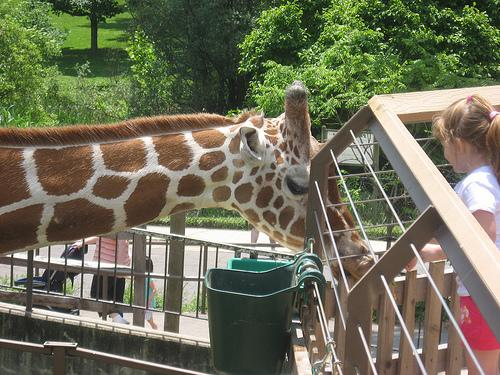Point out a few details about the giraffe's physical appearance. The giraffe has a brown and white pattern on its neck, downward-looking eyes, and horns on its head. List the primary human activities happening in the image. Little girl feeding giraffe, woman pushing baby stroller, child walking beside the stroller. Briefly describe the appearance of the trees in the scene. The trees have green leaves and stand tall in the background, providing a lush backdrop for the scene. In a few words, describe where the giraffe's food is placed and its color. The giraffe's food is in two green feed buckets near the wooden railing. Explain the position of the giraffe's head and what it appears to be doing. The giraffe's head is lowered, and its eye is looking downward as it eats from the girl's hand. Mention what surrounds the giraffe's living area in the image. There is a wooden railing and fencing around the giraffe's pen, as well as green trees in the background. Provide a brief description of the parent-child scene in the image. A woman wearing a pink striped shirt is pushing a baby stroller on the sidewalk as a child walks beside her. Describe the color and appearance of the girl's outfit in the image. The girl is wearing a green top, pink shorts, and has her blonde hair pulled back in a ponytail with a pink hair tie. Mention the two primary subjects in the image and what action they are performing. A little girl in a green top and red shorts is feeding a giraffe with brown spots and a long neck at the zoo. Explain the interaction between the girl and the giraffe in the image. The little girl in pink shorts is standing by the wooden railing and reaching out to feed the giraffe who leans down to eat from her hand. 